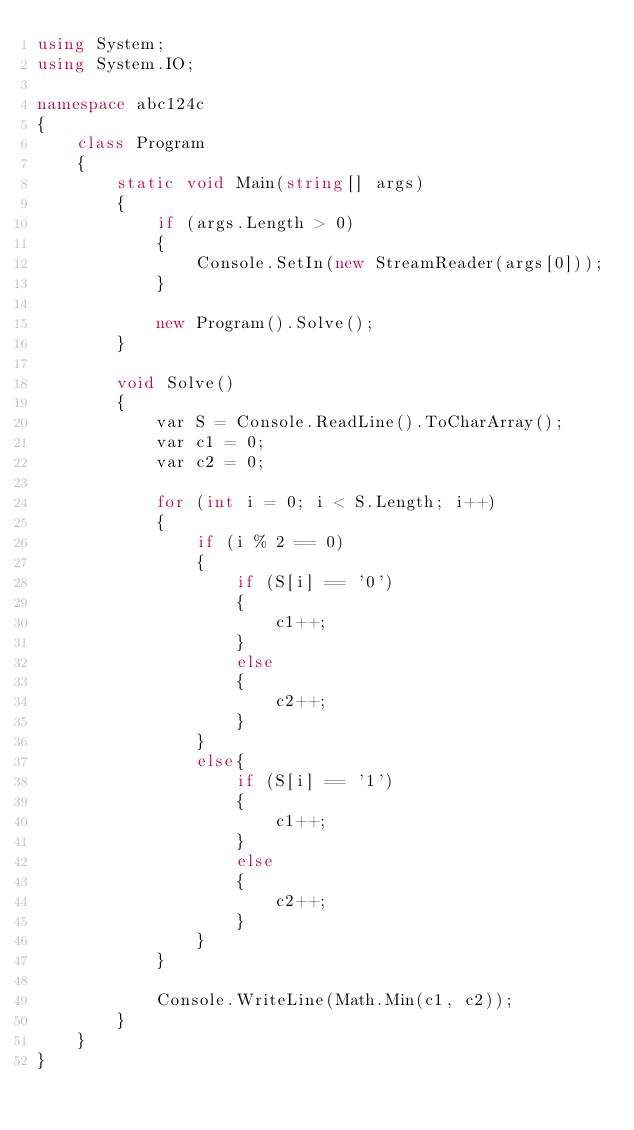<code> <loc_0><loc_0><loc_500><loc_500><_C#_>using System;
using System.IO;

namespace abc124c
{
    class Program
    {
        static void Main(string[] args)
        {
            if (args.Length > 0)
            {
                Console.SetIn(new StreamReader(args[0]));
            }

            new Program().Solve();
        }

        void Solve()
        {
            var S = Console.ReadLine().ToCharArray();
            var c1 = 0;
            var c2 = 0;

            for (int i = 0; i < S.Length; i++)
            {
                if (i % 2 == 0)
                {
                    if (S[i] == '0')
                    {
                        c1++;
                    }
                    else
                    {
                        c2++;
                    }
                }
                else{
                    if (S[i] == '1')
                    {
                        c1++;
                    }
                    else
                    {
                        c2++;
                    }
                }
            }

            Console.WriteLine(Math.Min(c1, c2));
        }
    }
}
</code> 